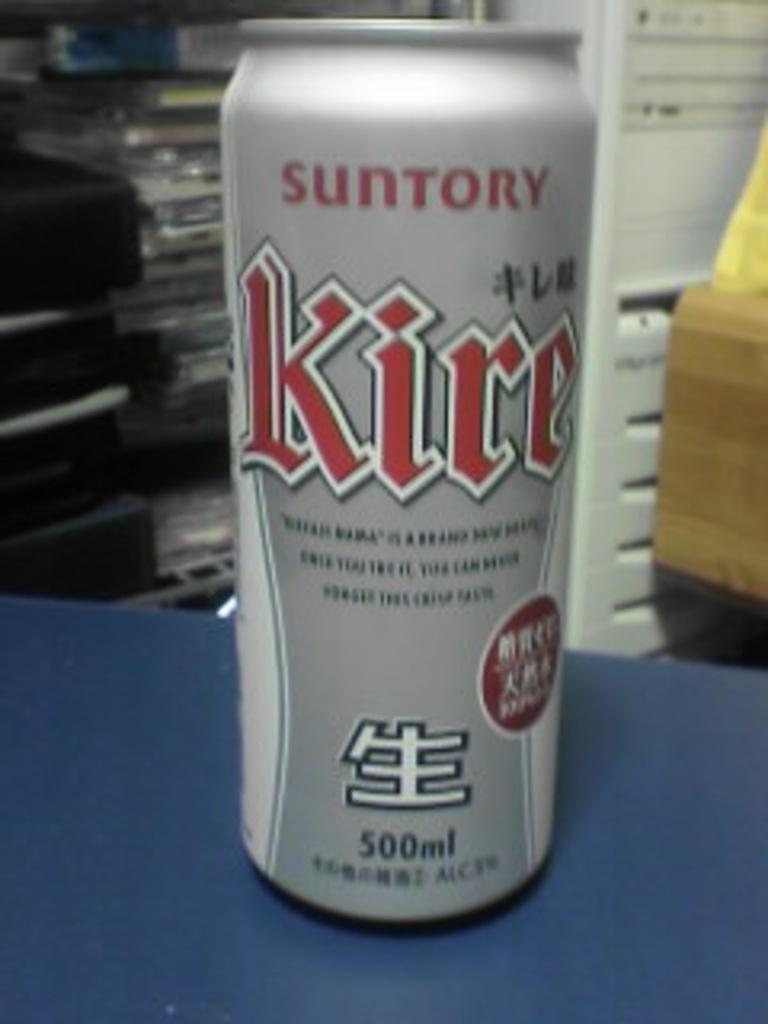What object is on the table in the image? There is a tin on a table in the image. What type of quill is being used to write on the tin in the image? There is no quill or writing present on the tin in the image. How many steps are visible leading up to the table in the image? There are no steps visible in the image; it only shows a table with a tin on it. 